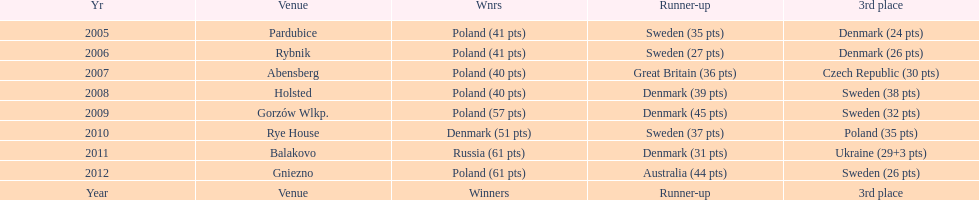In which most recent year did the 3rd place finisher score less than 25 points? 2005. 